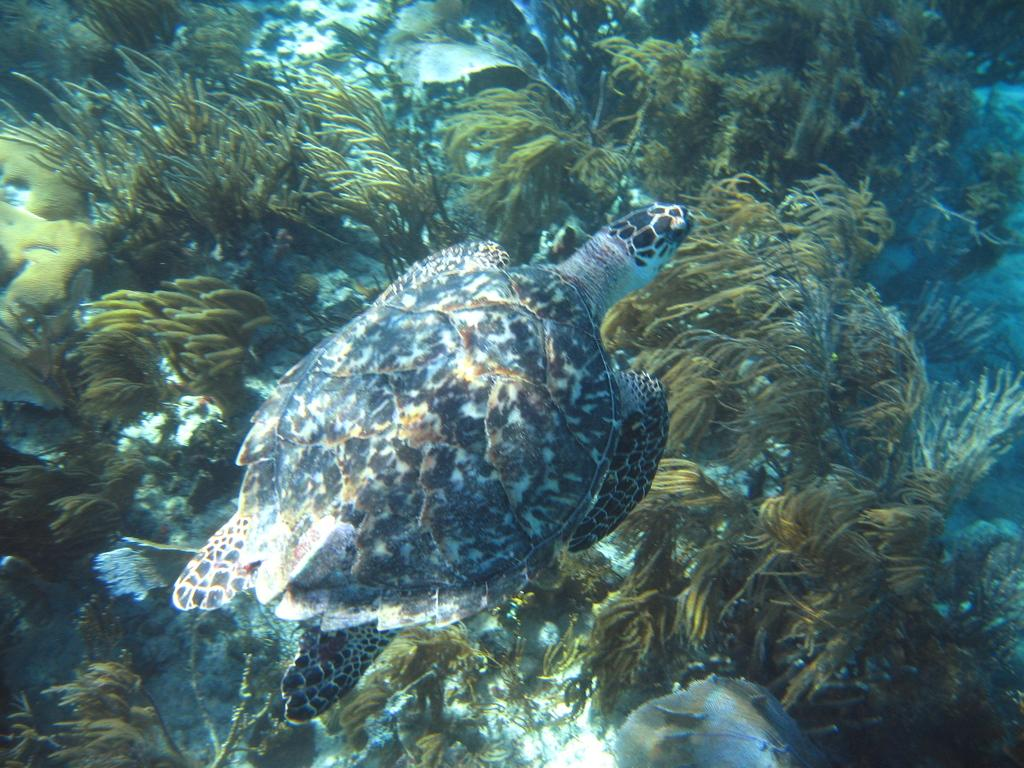What is the main subject in the center of the image? There is a tortoise in the center of the image. Where is the tortoise located? The tortoise is in the water. What type of vegetation can be seen around the area of the image? There are aquatic plants around the area of the image. What advice does the tortoise's mom give in the image? There is no reference to a tortoise's mom or any advice in the image. 